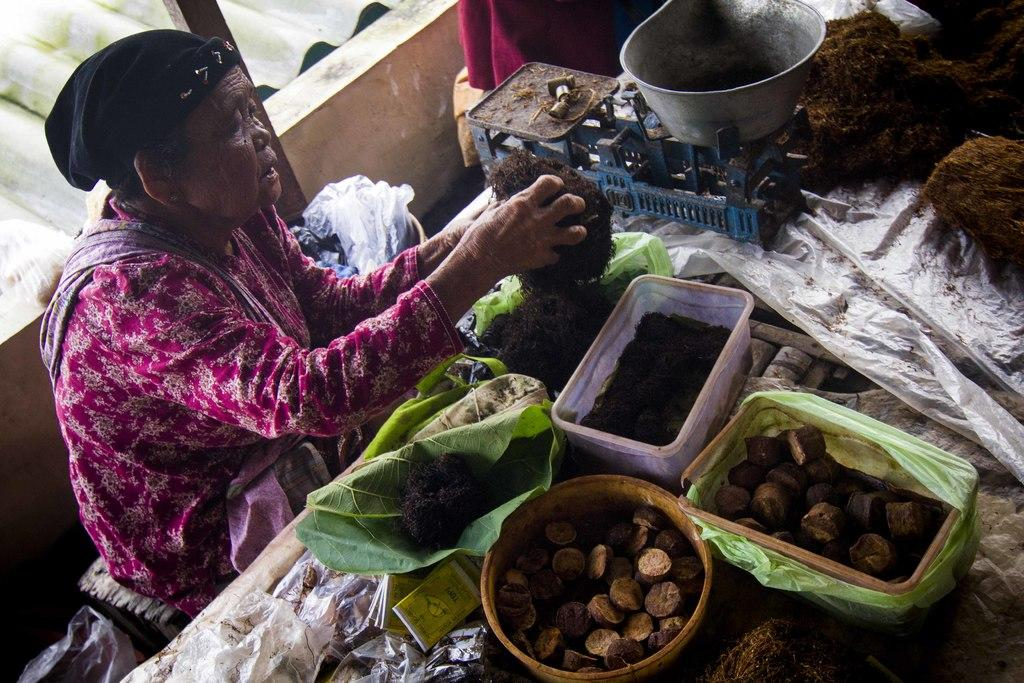Who is present in the image? There is a woman in the image. What is the primary object in the image? There is a table in the image. What type of material is covering some objects in the image? There are plastic covers in the image. What type of containers can be seen in the image? There are boxes in the image. What natural elements are present in the image? There are leaves in the image. What type of construction material is visible in the image? There is a roof sheet in the image. What architectural feature is present in the image? There is a wall in the image. What device is used for measuring weight in the image? There is a weighing scale in the image. Can you describe any additional objects in the image? There are additional objects in the image, but their specific details are not mentioned in the provided facts. What type of credit card is the woman using to pay for her lunch in the image? There is no credit card or lunch depicted in the image, so it is not possible to determine what type of credit card the woman might be using or what she might be paying for. 